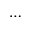<formula> <loc_0><loc_0><loc_500><loc_500>\cdots</formula> 